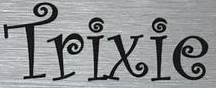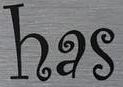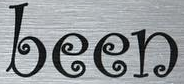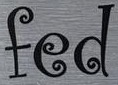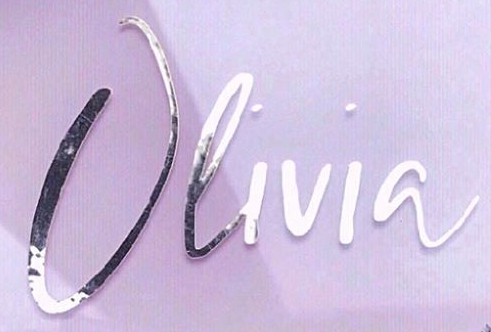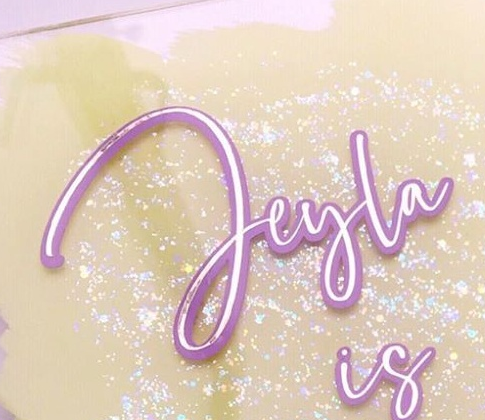Transcribe the words shown in these images in order, separated by a semicolon. Trixie; has; been; fed; Olivia; Jeyla 